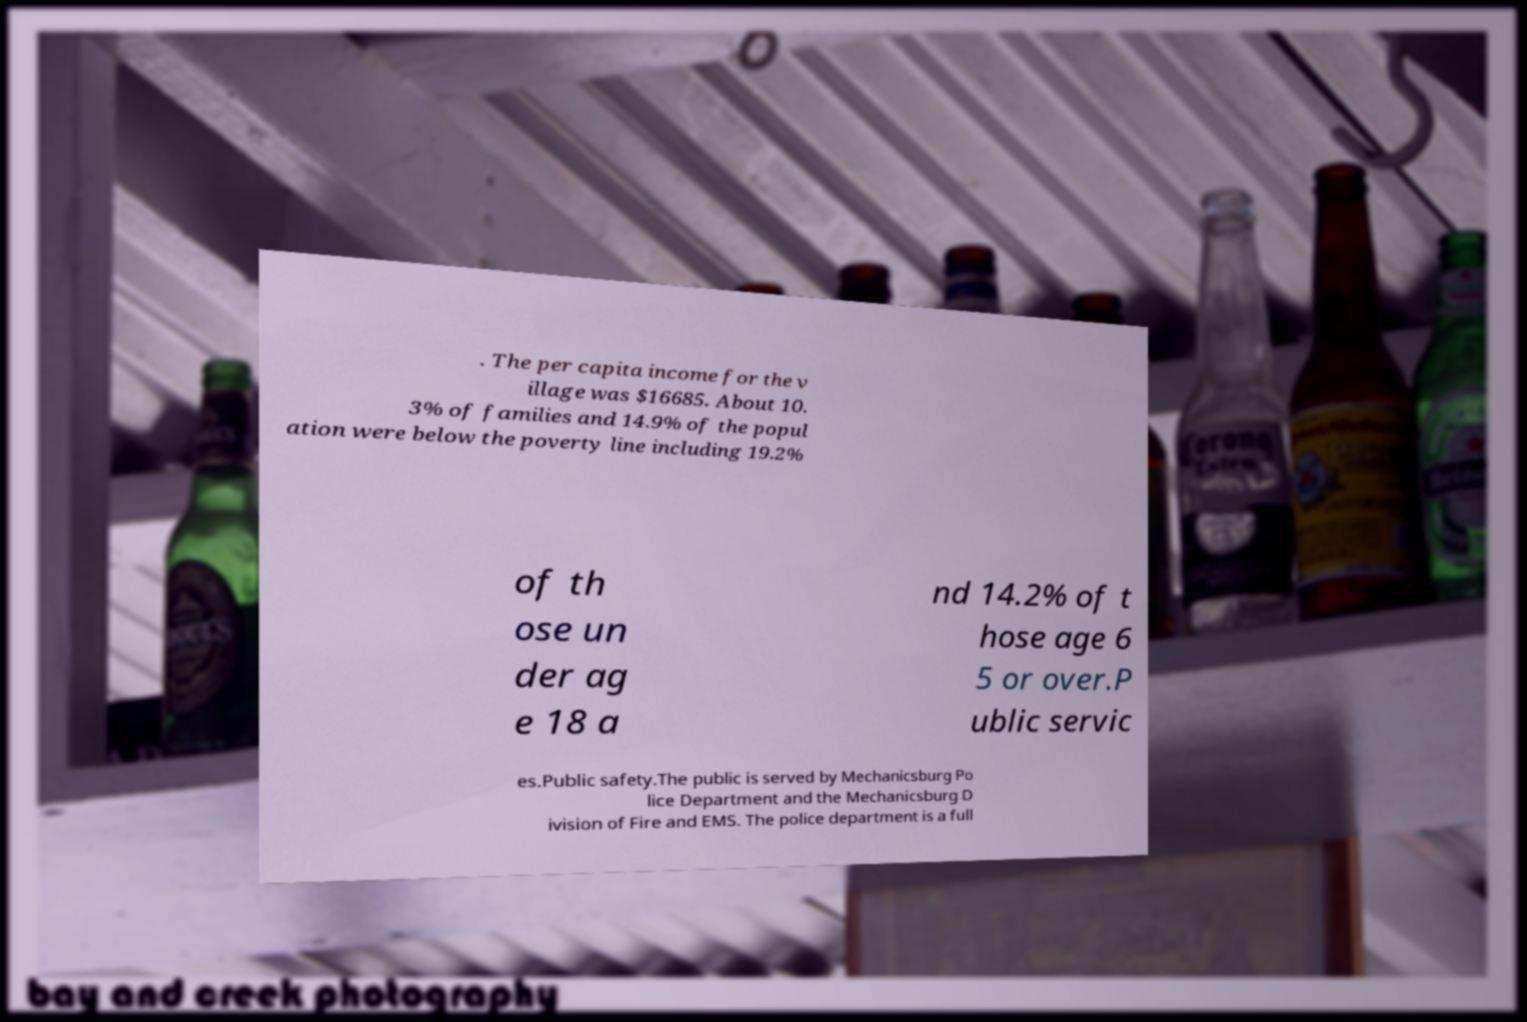I need the written content from this picture converted into text. Can you do that? . The per capita income for the v illage was $16685. About 10. 3% of families and 14.9% of the popul ation were below the poverty line including 19.2% of th ose un der ag e 18 a nd 14.2% of t hose age 6 5 or over.P ublic servic es.Public safety.The public is served by Mechanicsburg Po lice Department and the Mechanicsburg D ivision of Fire and EMS. The police department is a full 